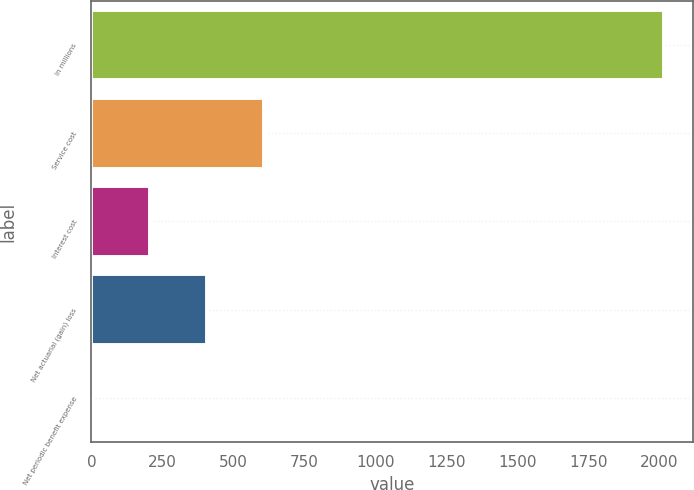<chart> <loc_0><loc_0><loc_500><loc_500><bar_chart><fcel>In millions<fcel>Service cost<fcel>Interest cost<fcel>Net actuarial (gain) loss<fcel>Net periodic benefit expense<nl><fcel>2017<fcel>607.41<fcel>204.67<fcel>406.04<fcel>3.3<nl></chart> 